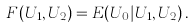Convert formula to latex. <formula><loc_0><loc_0><loc_500><loc_500>F ( U _ { 1 } , U _ { 2 } ) = E ( U _ { 0 } | U _ { 1 } , U _ { 2 } ) \, .</formula> 